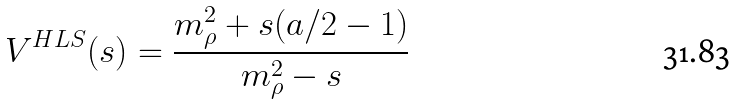<formula> <loc_0><loc_0><loc_500><loc_500>V ^ { H L S } ( s ) = \frac { m _ { \rho } ^ { 2 } + s ( a / 2 - 1 ) } { m _ { \rho } ^ { 2 } - s }</formula> 